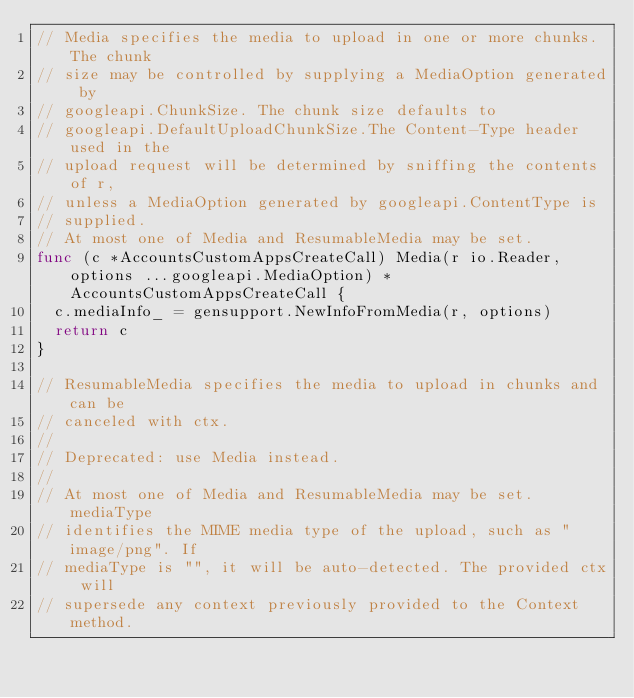<code> <loc_0><loc_0><loc_500><loc_500><_Go_>// Media specifies the media to upload in one or more chunks. The chunk
// size may be controlled by supplying a MediaOption generated by
// googleapi.ChunkSize. The chunk size defaults to
// googleapi.DefaultUploadChunkSize.The Content-Type header used in the
// upload request will be determined by sniffing the contents of r,
// unless a MediaOption generated by googleapi.ContentType is
// supplied.
// At most one of Media and ResumableMedia may be set.
func (c *AccountsCustomAppsCreateCall) Media(r io.Reader, options ...googleapi.MediaOption) *AccountsCustomAppsCreateCall {
	c.mediaInfo_ = gensupport.NewInfoFromMedia(r, options)
	return c
}

// ResumableMedia specifies the media to upload in chunks and can be
// canceled with ctx.
//
// Deprecated: use Media instead.
//
// At most one of Media and ResumableMedia may be set. mediaType
// identifies the MIME media type of the upload, such as "image/png". If
// mediaType is "", it will be auto-detected. The provided ctx will
// supersede any context previously provided to the Context method.</code> 